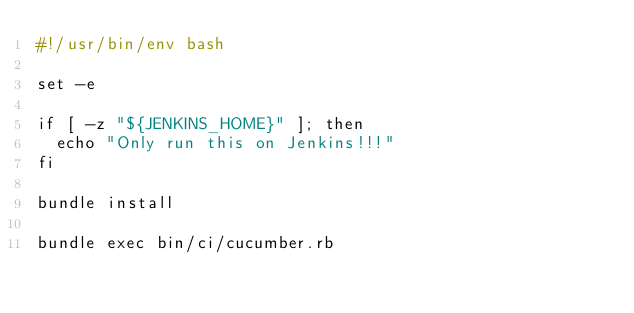<code> <loc_0><loc_0><loc_500><loc_500><_Bash_>#!/usr/bin/env bash

set -e

if [ -z "${JENKINS_HOME}" ]; then
  echo "Only run this on Jenkins!!!"
fi

bundle install

bundle exec bin/ci/cucumber.rb
</code> 